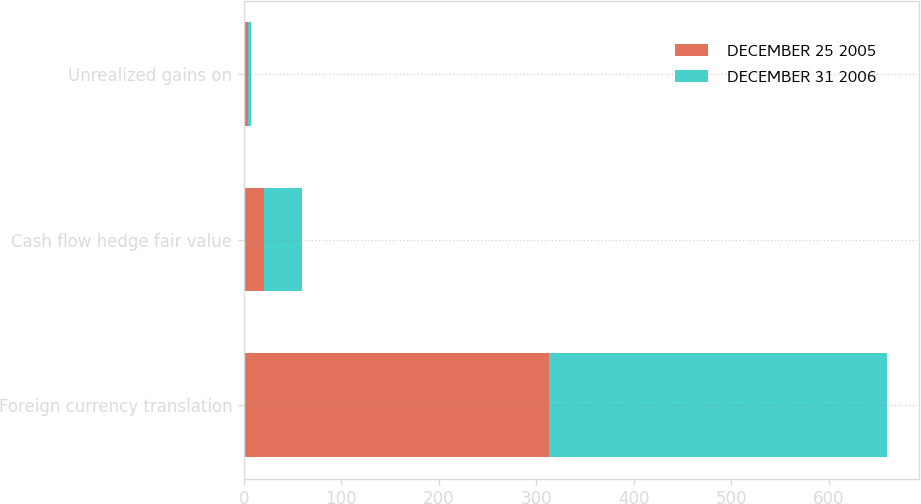Convert chart to OTSL. <chart><loc_0><loc_0><loc_500><loc_500><stacked_bar_chart><ecel><fcel>Foreign currency translation<fcel>Cash flow hedge fair value<fcel>Unrealized gains on<nl><fcel>DECEMBER 25 2005<fcel>313<fcel>21<fcel>4<nl><fcel>DECEMBER 31 2006<fcel>347<fcel>39<fcel>3<nl></chart> 